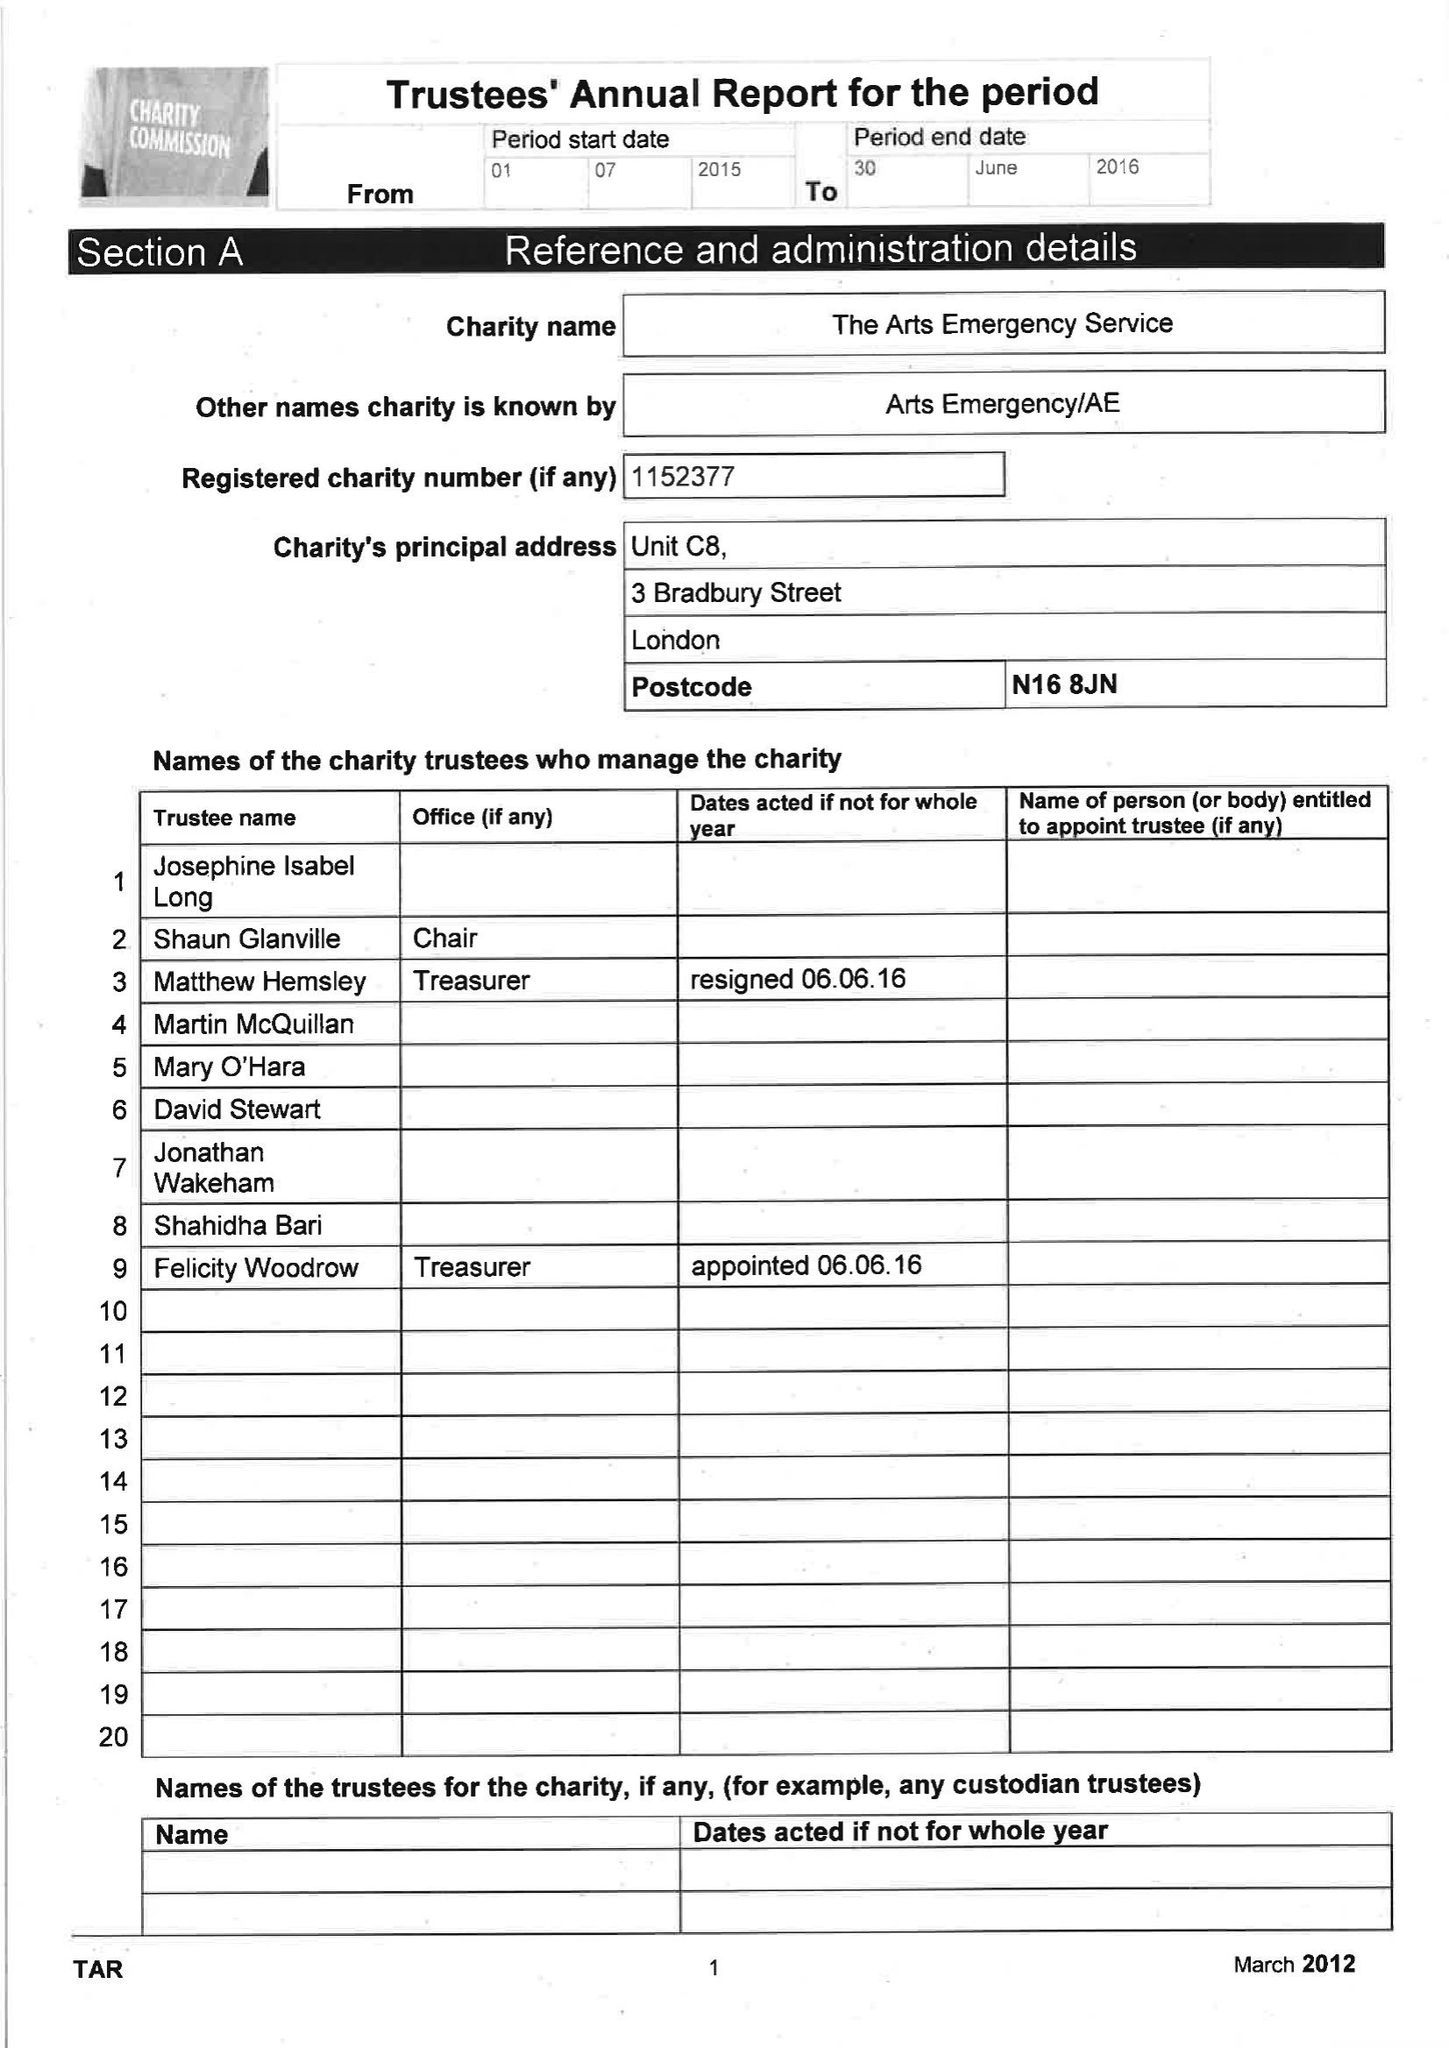What is the value for the charity_name?
Answer the question using a single word or phrase. The Arts Emergency Service 